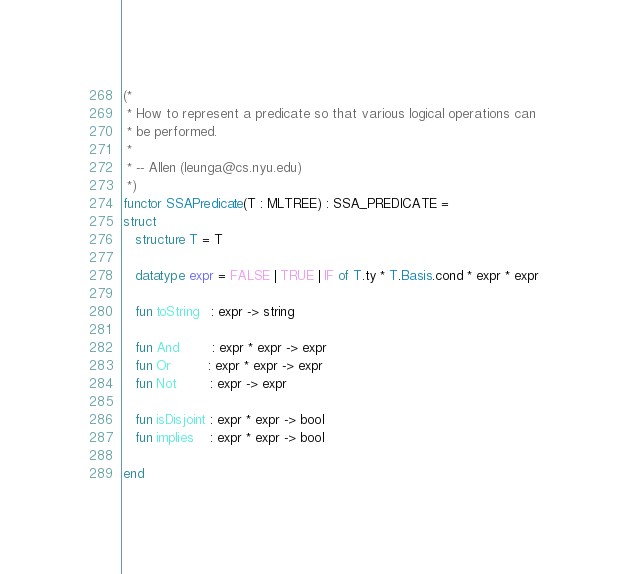Convert code to text. <code><loc_0><loc_0><loc_500><loc_500><_SML_>(*
 * How to represent a predicate so that various logical operations can
 * be performed.
 *
 * -- Allen (leunga@cs.nyu.edu)
 *)
functor SSAPredicate(T : MLTREE) : SSA_PREDICATE =
struct
   structure T = T

   datatype expr = FALSE | TRUE | IF of T.ty * T.Basis.cond * expr * expr

   fun toString   : expr -> string

   fun And        : expr * expr -> expr
   fun Or         : expr * expr -> expr
   fun Not        : expr -> expr

   fun isDisjoint : expr * expr -> bool
   fun implies    : expr * expr -> bool

end
</code> 